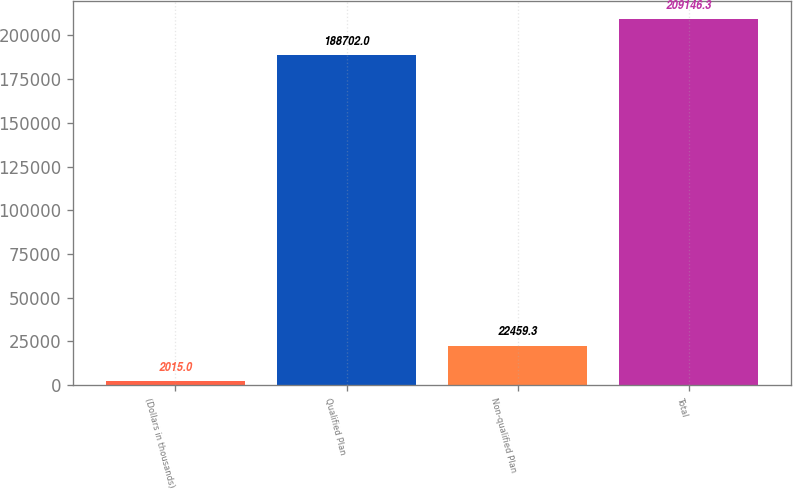Convert chart to OTSL. <chart><loc_0><loc_0><loc_500><loc_500><bar_chart><fcel>(Dollars in thousands)<fcel>Qualified Plan<fcel>Non-qualified Plan<fcel>Total<nl><fcel>2015<fcel>188702<fcel>22459.3<fcel>209146<nl></chart> 